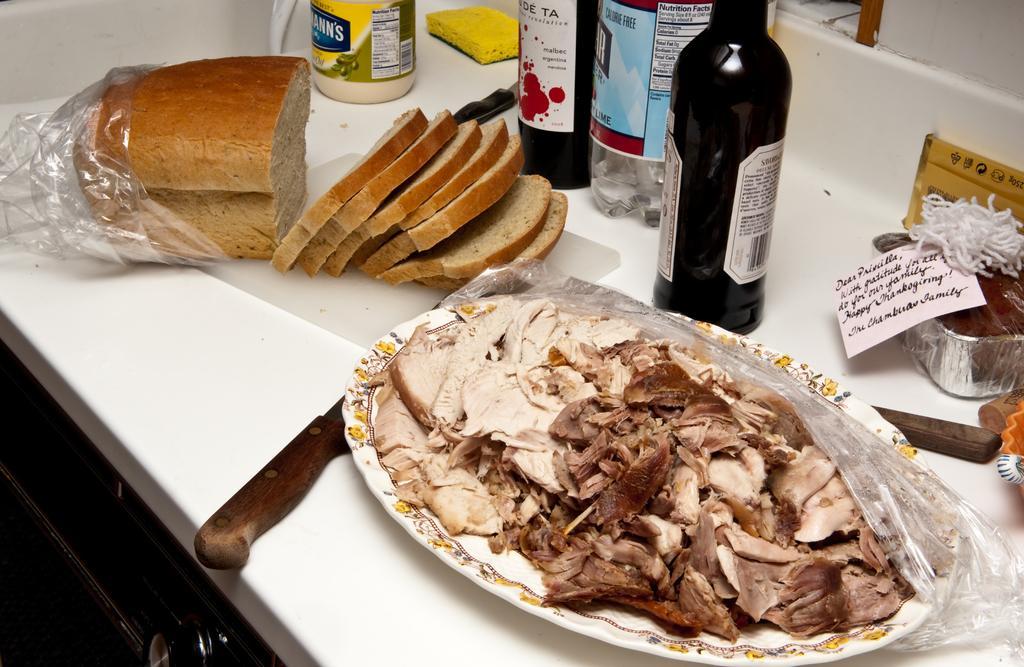How would you summarize this image in a sentence or two? In the image there is a table and there are bottles, knives, cake, bread and a plate of meat which is placed on the table. In the background there is a wall. 